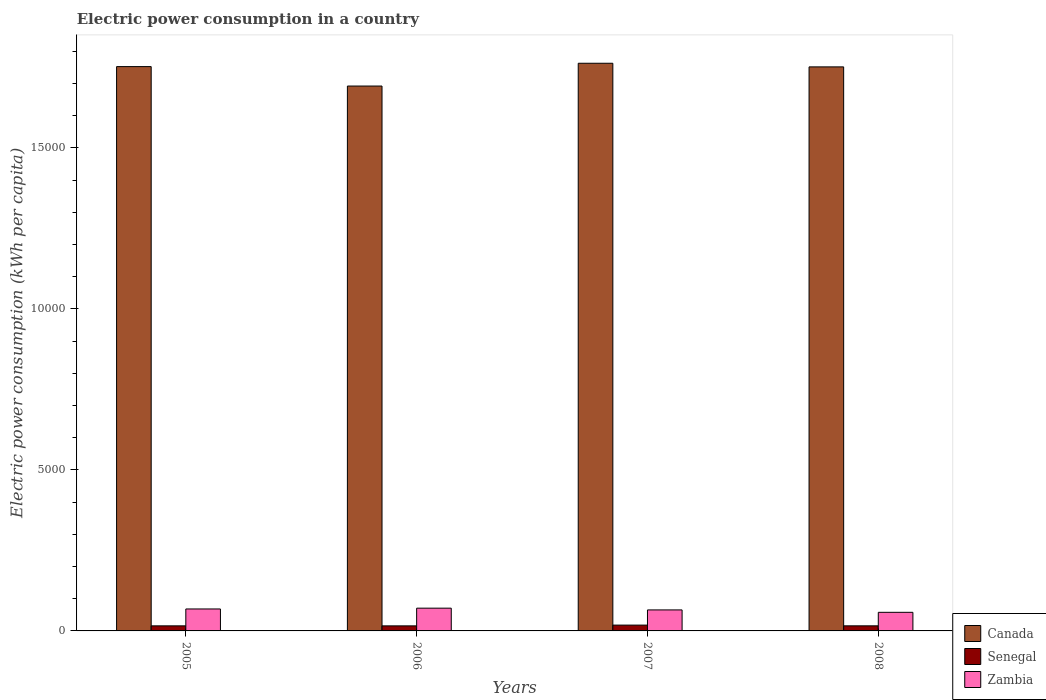Are the number of bars per tick equal to the number of legend labels?
Ensure brevity in your answer.  Yes. Are the number of bars on each tick of the X-axis equal?
Offer a terse response. Yes. How many bars are there on the 2nd tick from the left?
Your answer should be very brief. 3. What is the electric power consumption in in Zambia in 2006?
Ensure brevity in your answer.  707.02. Across all years, what is the maximum electric power consumption in in Zambia?
Provide a succinct answer. 707.02. Across all years, what is the minimum electric power consumption in in Canada?
Your answer should be compact. 1.69e+04. What is the total electric power consumption in in Senegal in the graph?
Your answer should be very brief. 653.31. What is the difference between the electric power consumption in in Zambia in 2005 and that in 2007?
Ensure brevity in your answer.  29.76. What is the difference between the electric power consumption in in Senegal in 2008 and the electric power consumption in in Zambia in 2006?
Provide a succinct answer. -549.05. What is the average electric power consumption in in Canada per year?
Provide a short and direct response. 1.74e+04. In the year 2008, what is the difference between the electric power consumption in in Zambia and electric power consumption in in Canada?
Make the answer very short. -1.69e+04. In how many years, is the electric power consumption in in Senegal greater than 1000 kWh per capita?
Keep it short and to the point. 0. What is the ratio of the electric power consumption in in Zambia in 2006 to that in 2008?
Your response must be concise. 1.22. What is the difference between the highest and the second highest electric power consumption in in Canada?
Make the answer very short. 103.99. What is the difference between the highest and the lowest electric power consumption in in Canada?
Offer a very short reply. 707.44. In how many years, is the electric power consumption in in Canada greater than the average electric power consumption in in Canada taken over all years?
Your answer should be very brief. 3. What does the 3rd bar from the left in 2008 represents?
Ensure brevity in your answer.  Zambia. What does the 2nd bar from the right in 2006 represents?
Your answer should be compact. Senegal. How many years are there in the graph?
Your response must be concise. 4. What is the difference between two consecutive major ticks on the Y-axis?
Ensure brevity in your answer.  5000. Does the graph contain any zero values?
Provide a succinct answer. No. Does the graph contain grids?
Provide a short and direct response. No. How many legend labels are there?
Offer a terse response. 3. How are the legend labels stacked?
Your answer should be compact. Vertical. What is the title of the graph?
Offer a very short reply. Electric power consumption in a country. What is the label or title of the X-axis?
Ensure brevity in your answer.  Years. What is the label or title of the Y-axis?
Your response must be concise. Electric power consumption (kWh per capita). What is the Electric power consumption (kWh per capita) of Canada in 2005?
Provide a succinct answer. 1.75e+04. What is the Electric power consumption (kWh per capita) in Senegal in 2005?
Make the answer very short. 157.69. What is the Electric power consumption (kWh per capita) of Zambia in 2005?
Your answer should be compact. 682.02. What is the Electric power consumption (kWh per capita) of Canada in 2006?
Your answer should be compact. 1.69e+04. What is the Electric power consumption (kWh per capita) of Senegal in 2006?
Provide a short and direct response. 156.84. What is the Electric power consumption (kWh per capita) of Zambia in 2006?
Ensure brevity in your answer.  707.02. What is the Electric power consumption (kWh per capita) in Canada in 2007?
Ensure brevity in your answer.  1.76e+04. What is the Electric power consumption (kWh per capita) in Senegal in 2007?
Give a very brief answer. 180.8. What is the Electric power consumption (kWh per capita) of Zambia in 2007?
Provide a succinct answer. 652.27. What is the Electric power consumption (kWh per capita) in Canada in 2008?
Offer a terse response. 1.75e+04. What is the Electric power consumption (kWh per capita) in Senegal in 2008?
Ensure brevity in your answer.  157.98. What is the Electric power consumption (kWh per capita) of Zambia in 2008?
Offer a very short reply. 577.91. Across all years, what is the maximum Electric power consumption (kWh per capita) of Canada?
Keep it short and to the point. 1.76e+04. Across all years, what is the maximum Electric power consumption (kWh per capita) in Senegal?
Provide a short and direct response. 180.8. Across all years, what is the maximum Electric power consumption (kWh per capita) in Zambia?
Keep it short and to the point. 707.02. Across all years, what is the minimum Electric power consumption (kWh per capita) of Canada?
Make the answer very short. 1.69e+04. Across all years, what is the minimum Electric power consumption (kWh per capita) of Senegal?
Give a very brief answer. 156.84. Across all years, what is the minimum Electric power consumption (kWh per capita) in Zambia?
Give a very brief answer. 577.91. What is the total Electric power consumption (kWh per capita) in Canada in the graph?
Offer a terse response. 6.96e+04. What is the total Electric power consumption (kWh per capita) of Senegal in the graph?
Make the answer very short. 653.31. What is the total Electric power consumption (kWh per capita) of Zambia in the graph?
Keep it short and to the point. 2619.22. What is the difference between the Electric power consumption (kWh per capita) of Canada in 2005 and that in 2006?
Offer a terse response. 603.45. What is the difference between the Electric power consumption (kWh per capita) of Senegal in 2005 and that in 2006?
Your response must be concise. 0.85. What is the difference between the Electric power consumption (kWh per capita) of Zambia in 2005 and that in 2006?
Offer a very short reply. -25. What is the difference between the Electric power consumption (kWh per capita) of Canada in 2005 and that in 2007?
Keep it short and to the point. -103.99. What is the difference between the Electric power consumption (kWh per capita) of Senegal in 2005 and that in 2007?
Offer a very short reply. -23.11. What is the difference between the Electric power consumption (kWh per capita) in Zambia in 2005 and that in 2007?
Offer a very short reply. 29.76. What is the difference between the Electric power consumption (kWh per capita) of Canada in 2005 and that in 2008?
Offer a terse response. 8.51. What is the difference between the Electric power consumption (kWh per capita) of Senegal in 2005 and that in 2008?
Provide a short and direct response. -0.29. What is the difference between the Electric power consumption (kWh per capita) in Zambia in 2005 and that in 2008?
Your answer should be very brief. 104.12. What is the difference between the Electric power consumption (kWh per capita) of Canada in 2006 and that in 2007?
Your response must be concise. -707.44. What is the difference between the Electric power consumption (kWh per capita) in Senegal in 2006 and that in 2007?
Your answer should be compact. -23.95. What is the difference between the Electric power consumption (kWh per capita) of Zambia in 2006 and that in 2007?
Offer a terse response. 54.76. What is the difference between the Electric power consumption (kWh per capita) of Canada in 2006 and that in 2008?
Your answer should be compact. -594.94. What is the difference between the Electric power consumption (kWh per capita) of Senegal in 2006 and that in 2008?
Your answer should be very brief. -1.13. What is the difference between the Electric power consumption (kWh per capita) in Zambia in 2006 and that in 2008?
Offer a very short reply. 129.12. What is the difference between the Electric power consumption (kWh per capita) of Canada in 2007 and that in 2008?
Your answer should be very brief. 112.5. What is the difference between the Electric power consumption (kWh per capita) in Senegal in 2007 and that in 2008?
Your answer should be very brief. 22.82. What is the difference between the Electric power consumption (kWh per capita) in Zambia in 2007 and that in 2008?
Your answer should be compact. 74.36. What is the difference between the Electric power consumption (kWh per capita) in Canada in 2005 and the Electric power consumption (kWh per capita) in Senegal in 2006?
Offer a terse response. 1.74e+04. What is the difference between the Electric power consumption (kWh per capita) of Canada in 2005 and the Electric power consumption (kWh per capita) of Zambia in 2006?
Your answer should be very brief. 1.68e+04. What is the difference between the Electric power consumption (kWh per capita) in Senegal in 2005 and the Electric power consumption (kWh per capita) in Zambia in 2006?
Your answer should be very brief. -549.33. What is the difference between the Electric power consumption (kWh per capita) of Canada in 2005 and the Electric power consumption (kWh per capita) of Senegal in 2007?
Your answer should be compact. 1.73e+04. What is the difference between the Electric power consumption (kWh per capita) of Canada in 2005 and the Electric power consumption (kWh per capita) of Zambia in 2007?
Your answer should be compact. 1.69e+04. What is the difference between the Electric power consumption (kWh per capita) of Senegal in 2005 and the Electric power consumption (kWh per capita) of Zambia in 2007?
Keep it short and to the point. -494.58. What is the difference between the Electric power consumption (kWh per capita) of Canada in 2005 and the Electric power consumption (kWh per capita) of Senegal in 2008?
Your answer should be compact. 1.74e+04. What is the difference between the Electric power consumption (kWh per capita) in Canada in 2005 and the Electric power consumption (kWh per capita) in Zambia in 2008?
Provide a succinct answer. 1.69e+04. What is the difference between the Electric power consumption (kWh per capita) in Senegal in 2005 and the Electric power consumption (kWh per capita) in Zambia in 2008?
Your answer should be very brief. -420.22. What is the difference between the Electric power consumption (kWh per capita) of Canada in 2006 and the Electric power consumption (kWh per capita) of Senegal in 2007?
Ensure brevity in your answer.  1.67e+04. What is the difference between the Electric power consumption (kWh per capita) in Canada in 2006 and the Electric power consumption (kWh per capita) in Zambia in 2007?
Make the answer very short. 1.63e+04. What is the difference between the Electric power consumption (kWh per capita) of Senegal in 2006 and the Electric power consumption (kWh per capita) of Zambia in 2007?
Ensure brevity in your answer.  -495.42. What is the difference between the Electric power consumption (kWh per capita) of Canada in 2006 and the Electric power consumption (kWh per capita) of Senegal in 2008?
Your response must be concise. 1.68e+04. What is the difference between the Electric power consumption (kWh per capita) of Canada in 2006 and the Electric power consumption (kWh per capita) of Zambia in 2008?
Offer a terse response. 1.63e+04. What is the difference between the Electric power consumption (kWh per capita) in Senegal in 2006 and the Electric power consumption (kWh per capita) in Zambia in 2008?
Give a very brief answer. -421.06. What is the difference between the Electric power consumption (kWh per capita) in Canada in 2007 and the Electric power consumption (kWh per capita) in Senegal in 2008?
Ensure brevity in your answer.  1.75e+04. What is the difference between the Electric power consumption (kWh per capita) of Canada in 2007 and the Electric power consumption (kWh per capita) of Zambia in 2008?
Give a very brief answer. 1.71e+04. What is the difference between the Electric power consumption (kWh per capita) in Senegal in 2007 and the Electric power consumption (kWh per capita) in Zambia in 2008?
Keep it short and to the point. -397.11. What is the average Electric power consumption (kWh per capita) in Canada per year?
Your answer should be compact. 1.74e+04. What is the average Electric power consumption (kWh per capita) of Senegal per year?
Offer a terse response. 163.33. What is the average Electric power consumption (kWh per capita) of Zambia per year?
Make the answer very short. 654.8. In the year 2005, what is the difference between the Electric power consumption (kWh per capita) of Canada and Electric power consumption (kWh per capita) of Senegal?
Give a very brief answer. 1.74e+04. In the year 2005, what is the difference between the Electric power consumption (kWh per capita) of Canada and Electric power consumption (kWh per capita) of Zambia?
Make the answer very short. 1.68e+04. In the year 2005, what is the difference between the Electric power consumption (kWh per capita) of Senegal and Electric power consumption (kWh per capita) of Zambia?
Your answer should be compact. -524.33. In the year 2006, what is the difference between the Electric power consumption (kWh per capita) of Canada and Electric power consumption (kWh per capita) of Senegal?
Ensure brevity in your answer.  1.68e+04. In the year 2006, what is the difference between the Electric power consumption (kWh per capita) in Canada and Electric power consumption (kWh per capita) in Zambia?
Your response must be concise. 1.62e+04. In the year 2006, what is the difference between the Electric power consumption (kWh per capita) in Senegal and Electric power consumption (kWh per capita) in Zambia?
Make the answer very short. -550.18. In the year 2007, what is the difference between the Electric power consumption (kWh per capita) of Canada and Electric power consumption (kWh per capita) of Senegal?
Give a very brief answer. 1.74e+04. In the year 2007, what is the difference between the Electric power consumption (kWh per capita) of Canada and Electric power consumption (kWh per capita) of Zambia?
Ensure brevity in your answer.  1.70e+04. In the year 2007, what is the difference between the Electric power consumption (kWh per capita) in Senegal and Electric power consumption (kWh per capita) in Zambia?
Your response must be concise. -471.47. In the year 2008, what is the difference between the Electric power consumption (kWh per capita) in Canada and Electric power consumption (kWh per capita) in Senegal?
Offer a terse response. 1.74e+04. In the year 2008, what is the difference between the Electric power consumption (kWh per capita) in Canada and Electric power consumption (kWh per capita) in Zambia?
Provide a succinct answer. 1.69e+04. In the year 2008, what is the difference between the Electric power consumption (kWh per capita) of Senegal and Electric power consumption (kWh per capita) of Zambia?
Offer a very short reply. -419.93. What is the ratio of the Electric power consumption (kWh per capita) of Canada in 2005 to that in 2006?
Offer a terse response. 1.04. What is the ratio of the Electric power consumption (kWh per capita) of Senegal in 2005 to that in 2006?
Give a very brief answer. 1.01. What is the ratio of the Electric power consumption (kWh per capita) of Zambia in 2005 to that in 2006?
Keep it short and to the point. 0.96. What is the ratio of the Electric power consumption (kWh per capita) of Senegal in 2005 to that in 2007?
Your answer should be compact. 0.87. What is the ratio of the Electric power consumption (kWh per capita) in Zambia in 2005 to that in 2007?
Your response must be concise. 1.05. What is the ratio of the Electric power consumption (kWh per capita) of Zambia in 2005 to that in 2008?
Your answer should be very brief. 1.18. What is the ratio of the Electric power consumption (kWh per capita) of Canada in 2006 to that in 2007?
Give a very brief answer. 0.96. What is the ratio of the Electric power consumption (kWh per capita) in Senegal in 2006 to that in 2007?
Provide a short and direct response. 0.87. What is the ratio of the Electric power consumption (kWh per capita) of Zambia in 2006 to that in 2007?
Make the answer very short. 1.08. What is the ratio of the Electric power consumption (kWh per capita) of Zambia in 2006 to that in 2008?
Your answer should be very brief. 1.22. What is the ratio of the Electric power consumption (kWh per capita) of Canada in 2007 to that in 2008?
Your answer should be compact. 1.01. What is the ratio of the Electric power consumption (kWh per capita) of Senegal in 2007 to that in 2008?
Your response must be concise. 1.14. What is the ratio of the Electric power consumption (kWh per capita) of Zambia in 2007 to that in 2008?
Your answer should be very brief. 1.13. What is the difference between the highest and the second highest Electric power consumption (kWh per capita) in Canada?
Keep it short and to the point. 103.99. What is the difference between the highest and the second highest Electric power consumption (kWh per capita) in Senegal?
Your answer should be very brief. 22.82. What is the difference between the highest and the second highest Electric power consumption (kWh per capita) of Zambia?
Your answer should be compact. 25. What is the difference between the highest and the lowest Electric power consumption (kWh per capita) of Canada?
Provide a short and direct response. 707.44. What is the difference between the highest and the lowest Electric power consumption (kWh per capita) of Senegal?
Ensure brevity in your answer.  23.95. What is the difference between the highest and the lowest Electric power consumption (kWh per capita) of Zambia?
Provide a succinct answer. 129.12. 